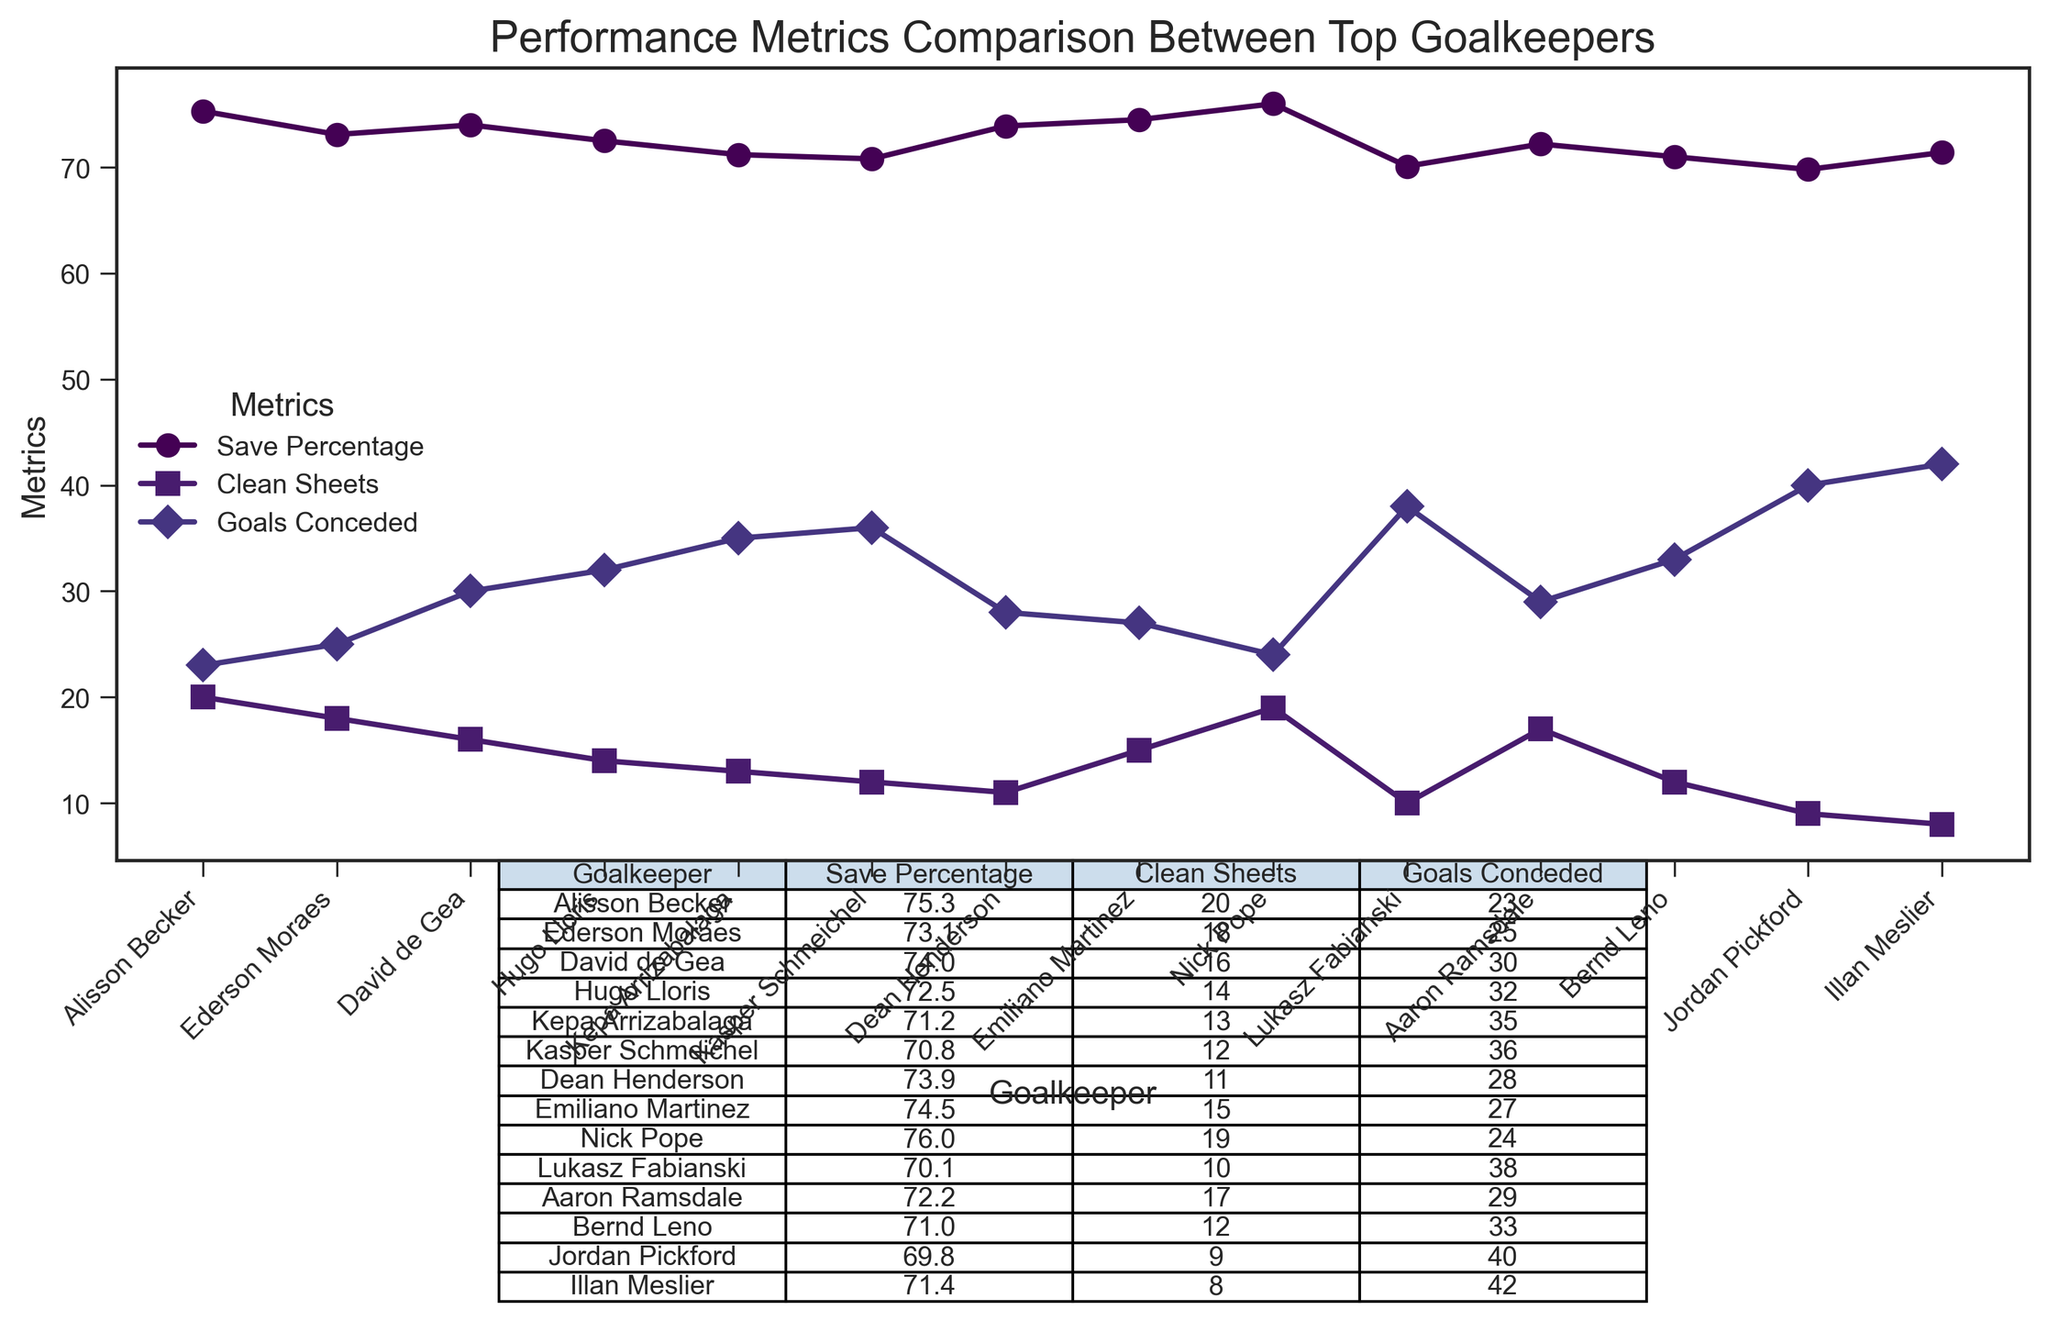Which goalkeeper has the highest save percentage? The plot shows the save percentage for each goalkeeper. By scanning the 'Save Percentage' line, we see that Nick Pope has the highest value.
Answer: Nick Pope Which goalkeeper has the fewest clean sheets? By looking at the 'Clean Sheets' line on the plot, we see that Jordan Pickford has the lowest value.
Answer: Jordan Pickford How many goals did Alisson Becker and Ederson Moraes concede in total? From the table, we see Alisson Becker conceded 23 goals and Ederson Moraes conceded 25 goals. Adding them up gives 23 + 25 = 48.
Answer: 48 Who has more clean sheets, Aaron Ramsdale or Bernd Leno? By comparing the 'Clean Sheets' values on the plot, we find that Aaron Ramsdale has 17 clean sheets, while Bernd Leno has 12 clean sheets.
Answer: Aaron Ramsdale Which goalkeeper has the lowest save percentage and how many clean sheets do they have? Lukasz Fabianski has the lowest save percentage of 70.1%. We then check his clean sheets value to find it is 10.
Answer: Lukasz Fabianski has 10 clean sheets What is the average number of goals conceded by Hugo Lloris, Kepa Arrizabalaga, and Kasper Schmeichel? The table shows Hugo Lloris conceded 32 goals, Kepa Arrizabalaga 35, and Kasper Schmeichel 36. The average is (32 + 35 + 36) / 3 = 34.33.
Answer: 34.33 Who has the second highest number of clean sheets? The plot shows the clean sheets for each goalkeeper. After Nick Pope with 19 clean sheets, Alisson Becker has the second highest with 20 clean sheets.
Answer: Alisson Becker Which goalkeeper has a higher save percentage: Emiliano Martinez or David de Gea? By comparing the 'Save Percentage' values on the plot, we see Emiliano Martinez has 74.5% while David de Gea has 74.0%.
Answer: Emiliano Martinez How many more goals did Illan Meslier concede compared to Dean Henderson? From the table, Illan Meslier conceded 42 goals and Dean Henderson conceded 28 goals. The difference is 42 - 28 = 14.
Answer: 14 Whose clean sheets number is closest to the average number of clean sheets, and what is this number? Summing clean sheets: (20 + 18 + 16 + 14 + 13 + 12 + 11 + 15 + 19 + 10 + 17 + 12 + 9 + 8) = 194. The average is 194 / 14 = 13.857. Kepa Arrizabalaga has 13 clean sheets, closest to 13.857.
Answer: Kepa Arrizabalaga, 13 